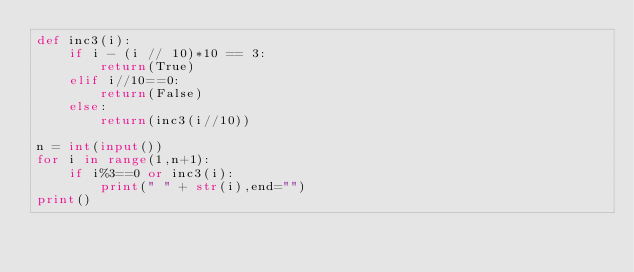<code> <loc_0><loc_0><loc_500><loc_500><_Python_>def inc3(i):
    if i - (i // 10)*10 == 3:
        return(True)
    elif i//10==0:
        return(False)
    else:    
        return(inc3(i//10))

n = int(input())
for i in range(1,n+1):
    if i%3==0 or inc3(i):
        print(" " + str(i),end="")
print()
</code> 